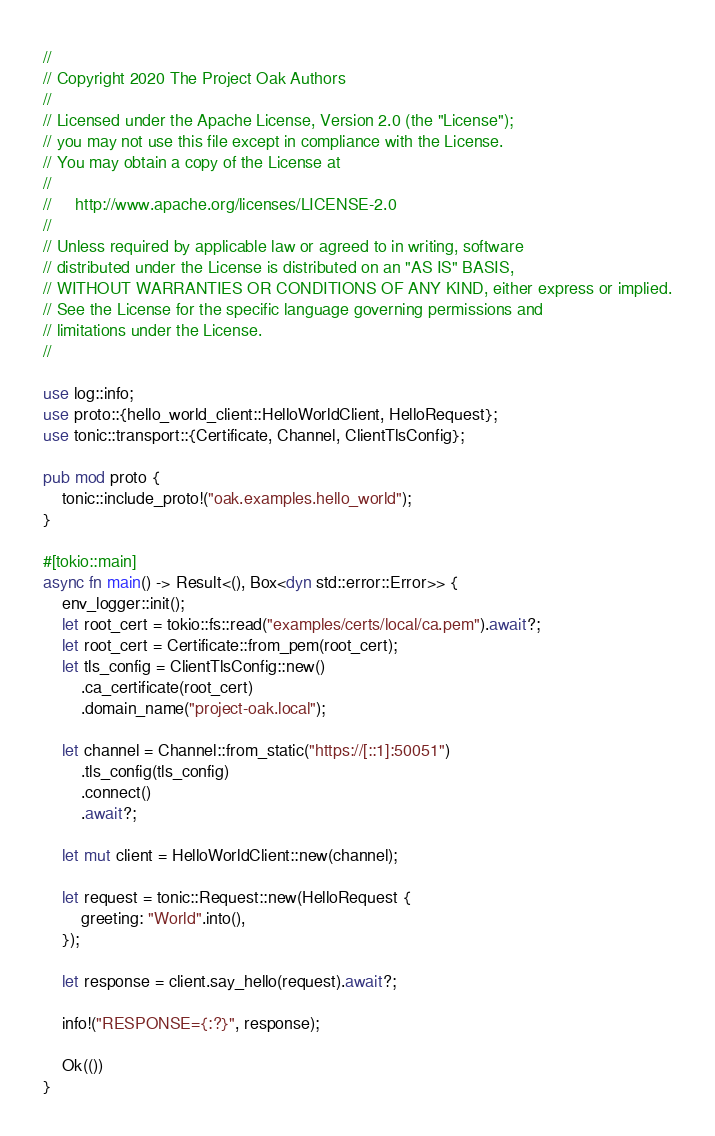<code> <loc_0><loc_0><loc_500><loc_500><_Rust_>//
// Copyright 2020 The Project Oak Authors
//
// Licensed under the Apache License, Version 2.0 (the "License");
// you may not use this file except in compliance with the License.
// You may obtain a copy of the License at
//
//     http://www.apache.org/licenses/LICENSE-2.0
//
// Unless required by applicable law or agreed to in writing, software
// distributed under the License is distributed on an "AS IS" BASIS,
// WITHOUT WARRANTIES OR CONDITIONS OF ANY KIND, either express or implied.
// See the License for the specific language governing permissions and
// limitations under the License.
//

use log::info;
use proto::{hello_world_client::HelloWorldClient, HelloRequest};
use tonic::transport::{Certificate, Channel, ClientTlsConfig};

pub mod proto {
    tonic::include_proto!("oak.examples.hello_world");
}

#[tokio::main]
async fn main() -> Result<(), Box<dyn std::error::Error>> {
    env_logger::init();
    let root_cert = tokio::fs::read("examples/certs/local/ca.pem").await?;
    let root_cert = Certificate::from_pem(root_cert);
    let tls_config = ClientTlsConfig::new()
        .ca_certificate(root_cert)
        .domain_name("project-oak.local");

    let channel = Channel::from_static("https://[::1]:50051")
        .tls_config(tls_config)
        .connect()
        .await?;

    let mut client = HelloWorldClient::new(channel);

    let request = tonic::Request::new(HelloRequest {
        greeting: "World".into(),
    });

    let response = client.say_hello(request).await?;

    info!("RESPONSE={:?}", response);

    Ok(())
}
</code> 